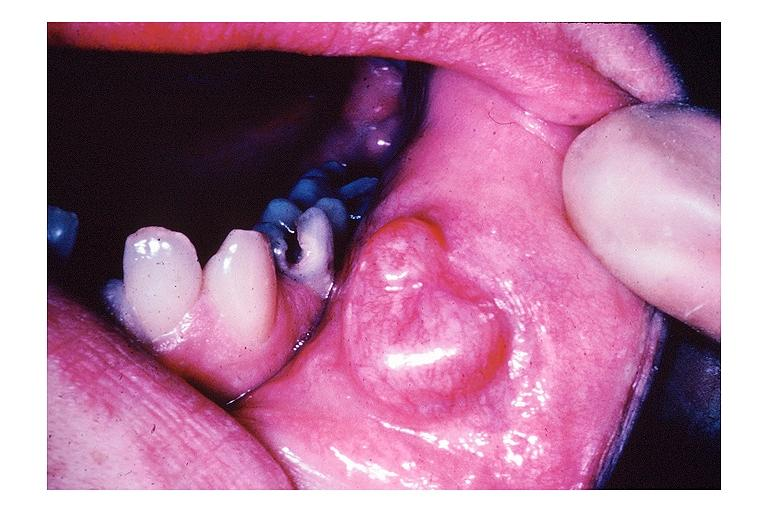does opened larynx show mucocele?
Answer the question using a single word or phrase. No 